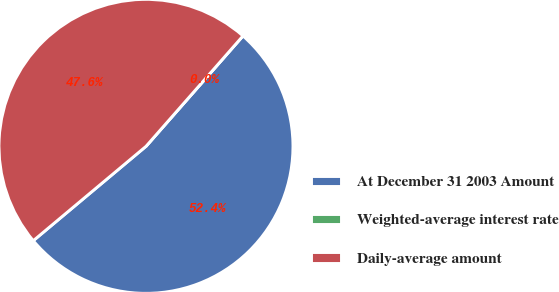Convert chart. <chart><loc_0><loc_0><loc_500><loc_500><pie_chart><fcel>At December 31 2003 Amount<fcel>Weighted-average interest rate<fcel>Daily-average amount<nl><fcel>52.44%<fcel>0.0%<fcel>47.56%<nl></chart> 